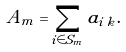<formula> <loc_0><loc_0><loc_500><loc_500>A _ { m } = \sum _ { i \in S _ { m } } a _ { i \, { k } } .</formula> 